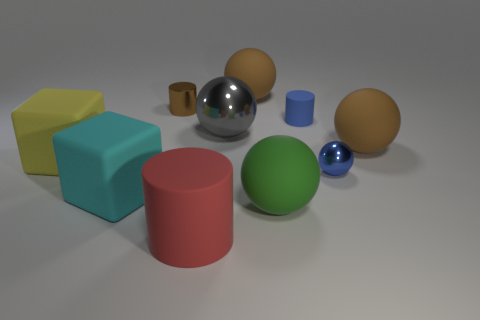Are there any large rubber things that have the same color as the tiny metallic ball?
Keep it short and to the point. No. Are there any brown balls made of the same material as the big cyan object?
Make the answer very short. Yes. There is a thing that is on the left side of the big gray metallic ball and behind the tiny blue cylinder; what is its shape?
Offer a terse response. Cylinder. How many big objects are either gray metal things or matte spheres?
Provide a short and direct response. 4. What is the large gray sphere made of?
Offer a terse response. Metal. How many other things are there of the same shape as the cyan matte thing?
Keep it short and to the point. 1. The blue ball is what size?
Provide a short and direct response. Small. What is the size of the matte sphere that is both behind the cyan cube and on the left side of the blue sphere?
Offer a very short reply. Large. What shape is the big thing that is left of the cyan matte object?
Offer a terse response. Cube. Is the material of the big yellow block the same as the brown object that is to the left of the big red object?
Ensure brevity in your answer.  No. 